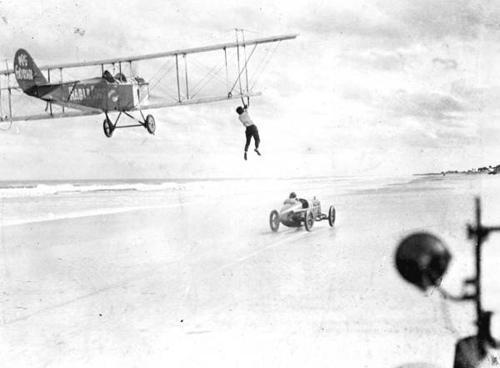How many vehicles are in this picture?
Give a very brief answer. 2. 